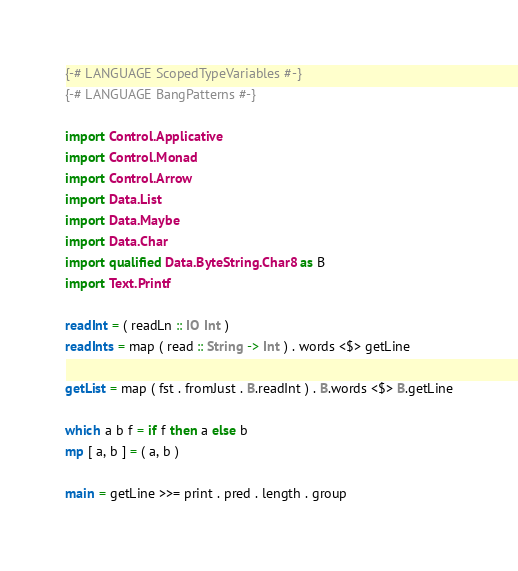<code> <loc_0><loc_0><loc_500><loc_500><_Haskell_>{-# LANGUAGE ScopedTypeVariables #-}
{-# LANGUAGE BangPatterns #-}

import Control.Applicative
import Control.Monad
import Control.Arrow
import Data.List
import Data.Maybe
import Data.Char
import qualified Data.ByteString.Char8 as B
import Text.Printf

readInt = ( readLn :: IO Int )
readInts = map ( read :: String -> Int ) . words <$> getLine

getList = map ( fst . fromJust . B.readInt ) . B.words <$> B.getLine

which a b f = if f then a else b
mp [ a, b ] = ( a, b )

main = getLine >>= print . pred . length . group
</code> 